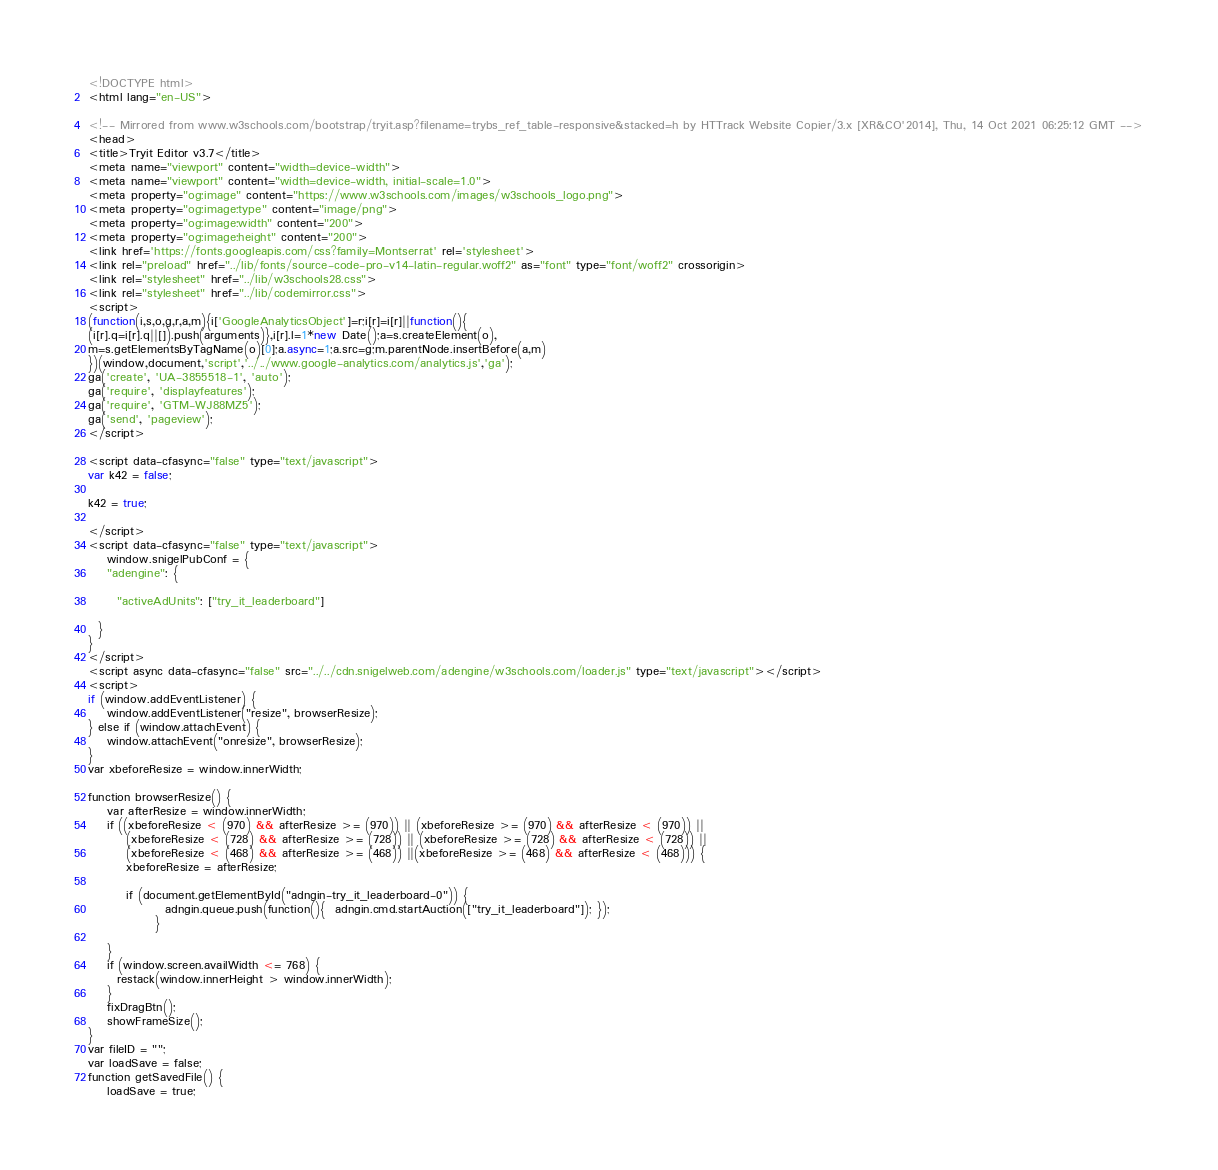<code> <loc_0><loc_0><loc_500><loc_500><_HTML_>
<!DOCTYPE html>
<html lang="en-US">

<!-- Mirrored from www.w3schools.com/bootstrap/tryit.asp?filename=trybs_ref_table-responsive&stacked=h by HTTrack Website Copier/3.x [XR&CO'2014], Thu, 14 Oct 2021 06:25:12 GMT -->
<head>
<title>Tryit Editor v3.7</title>
<meta name="viewport" content="width=device-width">
<meta name="viewport" content="width=device-width, initial-scale=1.0">
<meta property="og:image" content="https://www.w3schools.com/images/w3schools_logo.png">
<meta property="og:image:type" content="image/png">
<meta property="og:image:width" content="200">
<meta property="og:image:height" content="200">
<link href='https://fonts.googleapis.com/css?family=Montserrat' rel='stylesheet'>
<link rel="preload" href="../lib/fonts/source-code-pro-v14-latin-regular.woff2" as="font" type="font/woff2" crossorigin>
<link rel="stylesheet" href="../lib/w3schools28.css">
<link rel="stylesheet" href="../lib/codemirror.css">
<script>
(function(i,s,o,g,r,a,m){i['GoogleAnalyticsObject']=r;i[r]=i[r]||function(){
(i[r].q=i[r].q||[]).push(arguments)},i[r].l=1*new Date();a=s.createElement(o),
m=s.getElementsByTagName(o)[0];a.async=1;a.src=g;m.parentNode.insertBefore(a,m)
})(window,document,'script','../../www.google-analytics.com/analytics.js','ga');
ga('create', 'UA-3855518-1', 'auto');
ga('require', 'displayfeatures');
ga('require', 'GTM-WJ88MZ5');
ga('send', 'pageview');
</script>

<script data-cfasync="false" type="text/javascript">
var k42 = false;

k42 = true;

</script>
<script data-cfasync="false" type="text/javascript">
    window.snigelPubConf = {
    "adengine": {

      "activeAdUnits": ["try_it_leaderboard"]

  }
}
</script>
<script async data-cfasync="false" src="../../cdn.snigelweb.com/adengine/w3schools.com/loader.js" type="text/javascript"></script>
<script>
if (window.addEventListener) {              
    window.addEventListener("resize", browserResize);
} else if (window.attachEvent) {                 
    window.attachEvent("onresize", browserResize);
}
var xbeforeResize = window.innerWidth;

function browserResize() {
    var afterResize = window.innerWidth;
    if ((xbeforeResize < (970) && afterResize >= (970)) || (xbeforeResize >= (970) && afterResize < (970)) ||
        (xbeforeResize < (728) && afterResize >= (728)) || (xbeforeResize >= (728) && afterResize < (728)) ||
        (xbeforeResize < (468) && afterResize >= (468)) ||(xbeforeResize >= (468) && afterResize < (468))) {
        xbeforeResize = afterResize;
        
        if (document.getElementById("adngin-try_it_leaderboard-0")) {
                adngin.queue.push(function(){  adngin.cmd.startAuction(["try_it_leaderboard"]); });
              }
         
    }
    if (window.screen.availWidth <= 768) {
      restack(window.innerHeight > window.innerWidth);
    }
    fixDragBtn();
    showFrameSize();    
}
var fileID = "";
var loadSave = false;
function getSavedFile() {
    loadSave = true;</code> 